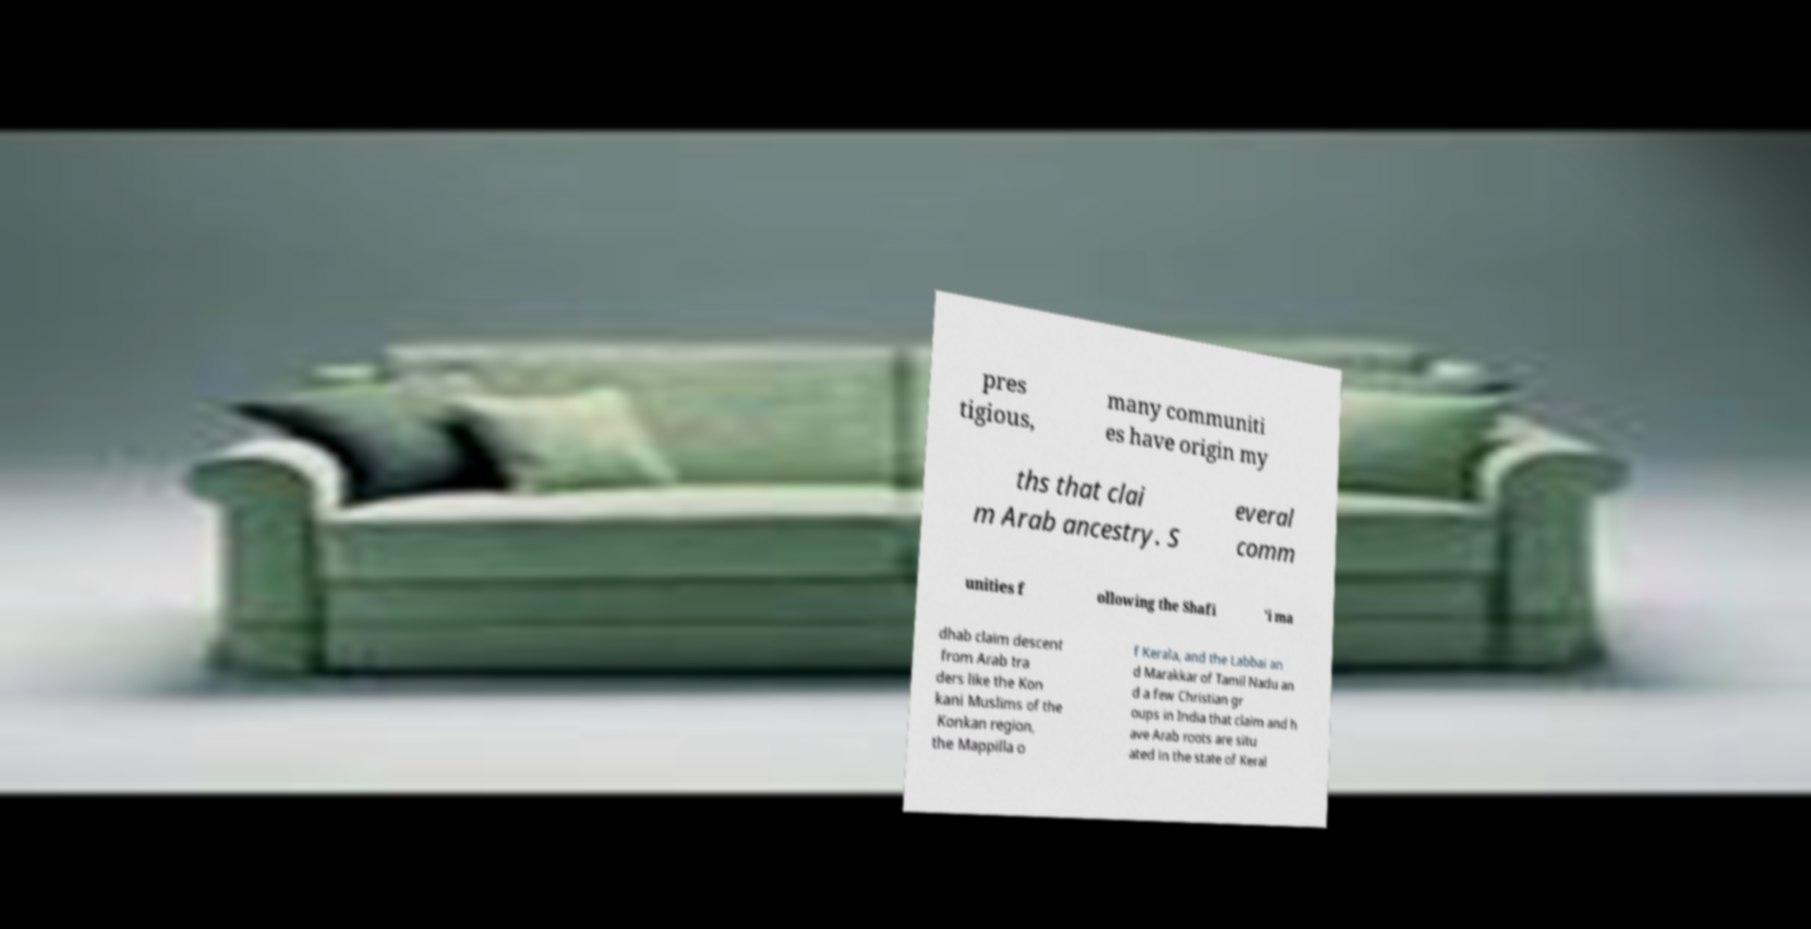Could you extract and type out the text from this image? pres tigious, many communiti es have origin my ths that clai m Arab ancestry. S everal comm unities f ollowing the Shafi 'i ma dhab claim descent from Arab tra ders like the Kon kani Muslims of the Konkan region, the Mappilla o f Kerala, and the Labbai an d Marakkar of Tamil Nadu an d a few Christian gr oups in India that claim and h ave Arab roots are situ ated in the state of Keral 